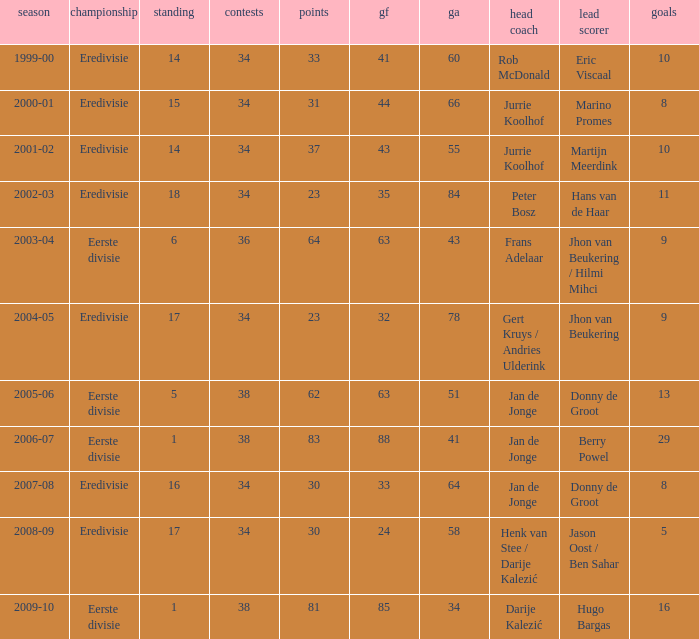How many goals were scored in the 2005-06 season? 13.0. 